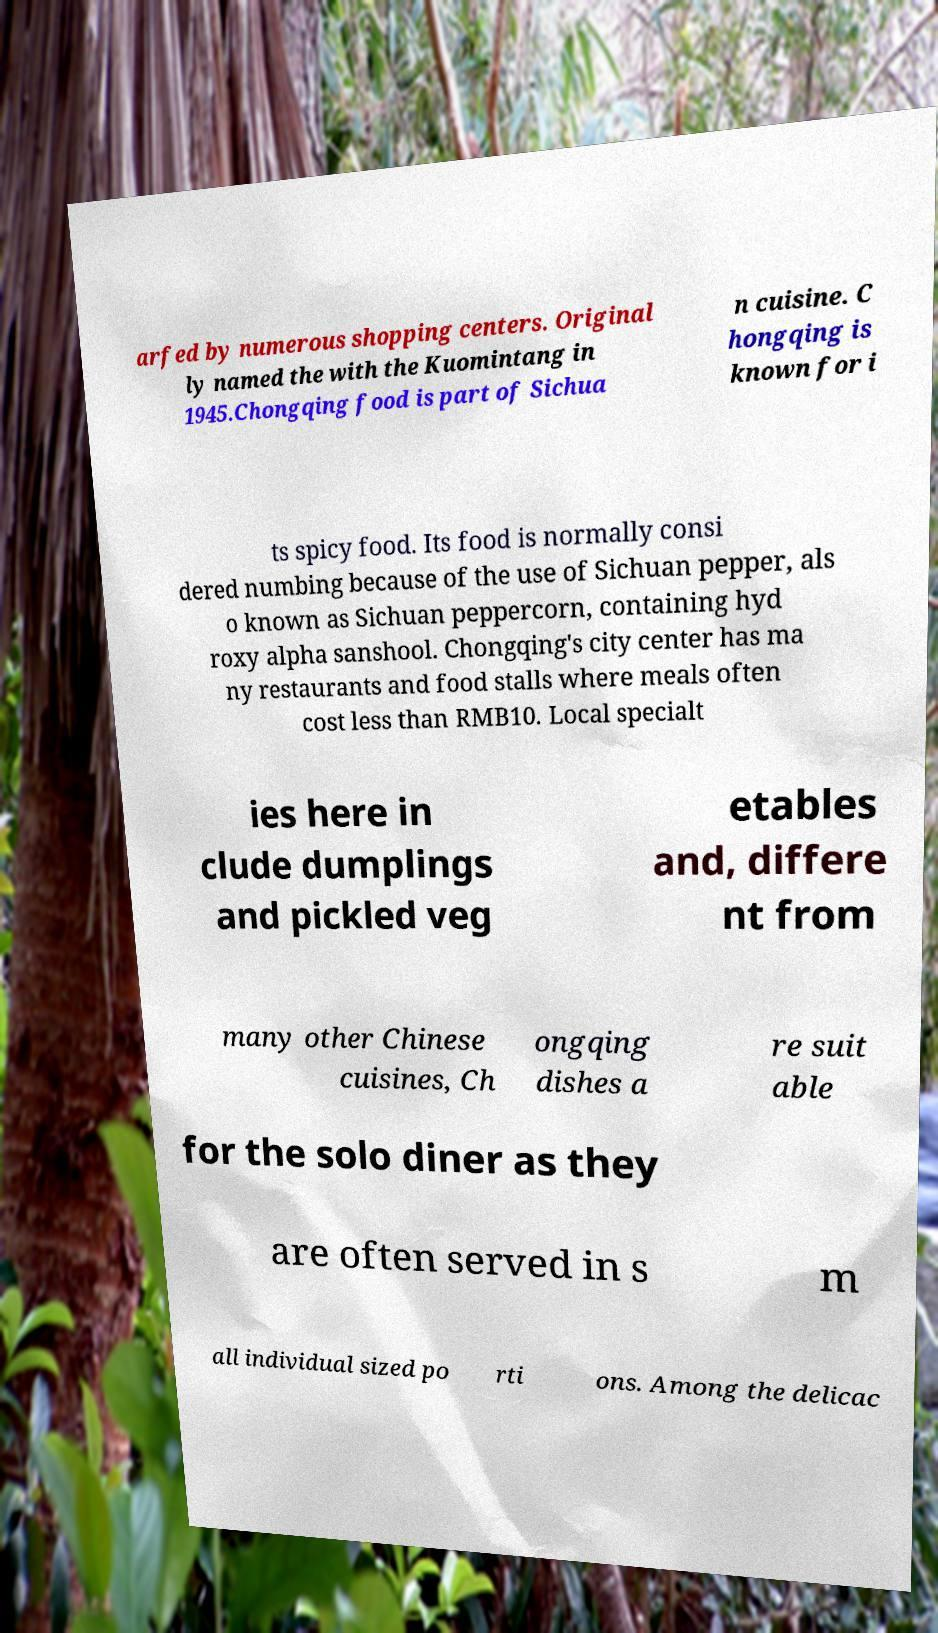Please identify and transcribe the text found in this image. arfed by numerous shopping centers. Original ly named the with the Kuomintang in 1945.Chongqing food is part of Sichua n cuisine. C hongqing is known for i ts spicy food. Its food is normally consi dered numbing because of the use of Sichuan pepper, als o known as Sichuan peppercorn, containing hyd roxy alpha sanshool. Chongqing's city center has ma ny restaurants and food stalls where meals often cost less than RMB10. Local specialt ies here in clude dumplings and pickled veg etables and, differe nt from many other Chinese cuisines, Ch ongqing dishes a re suit able for the solo diner as they are often served in s m all individual sized po rti ons. Among the delicac 